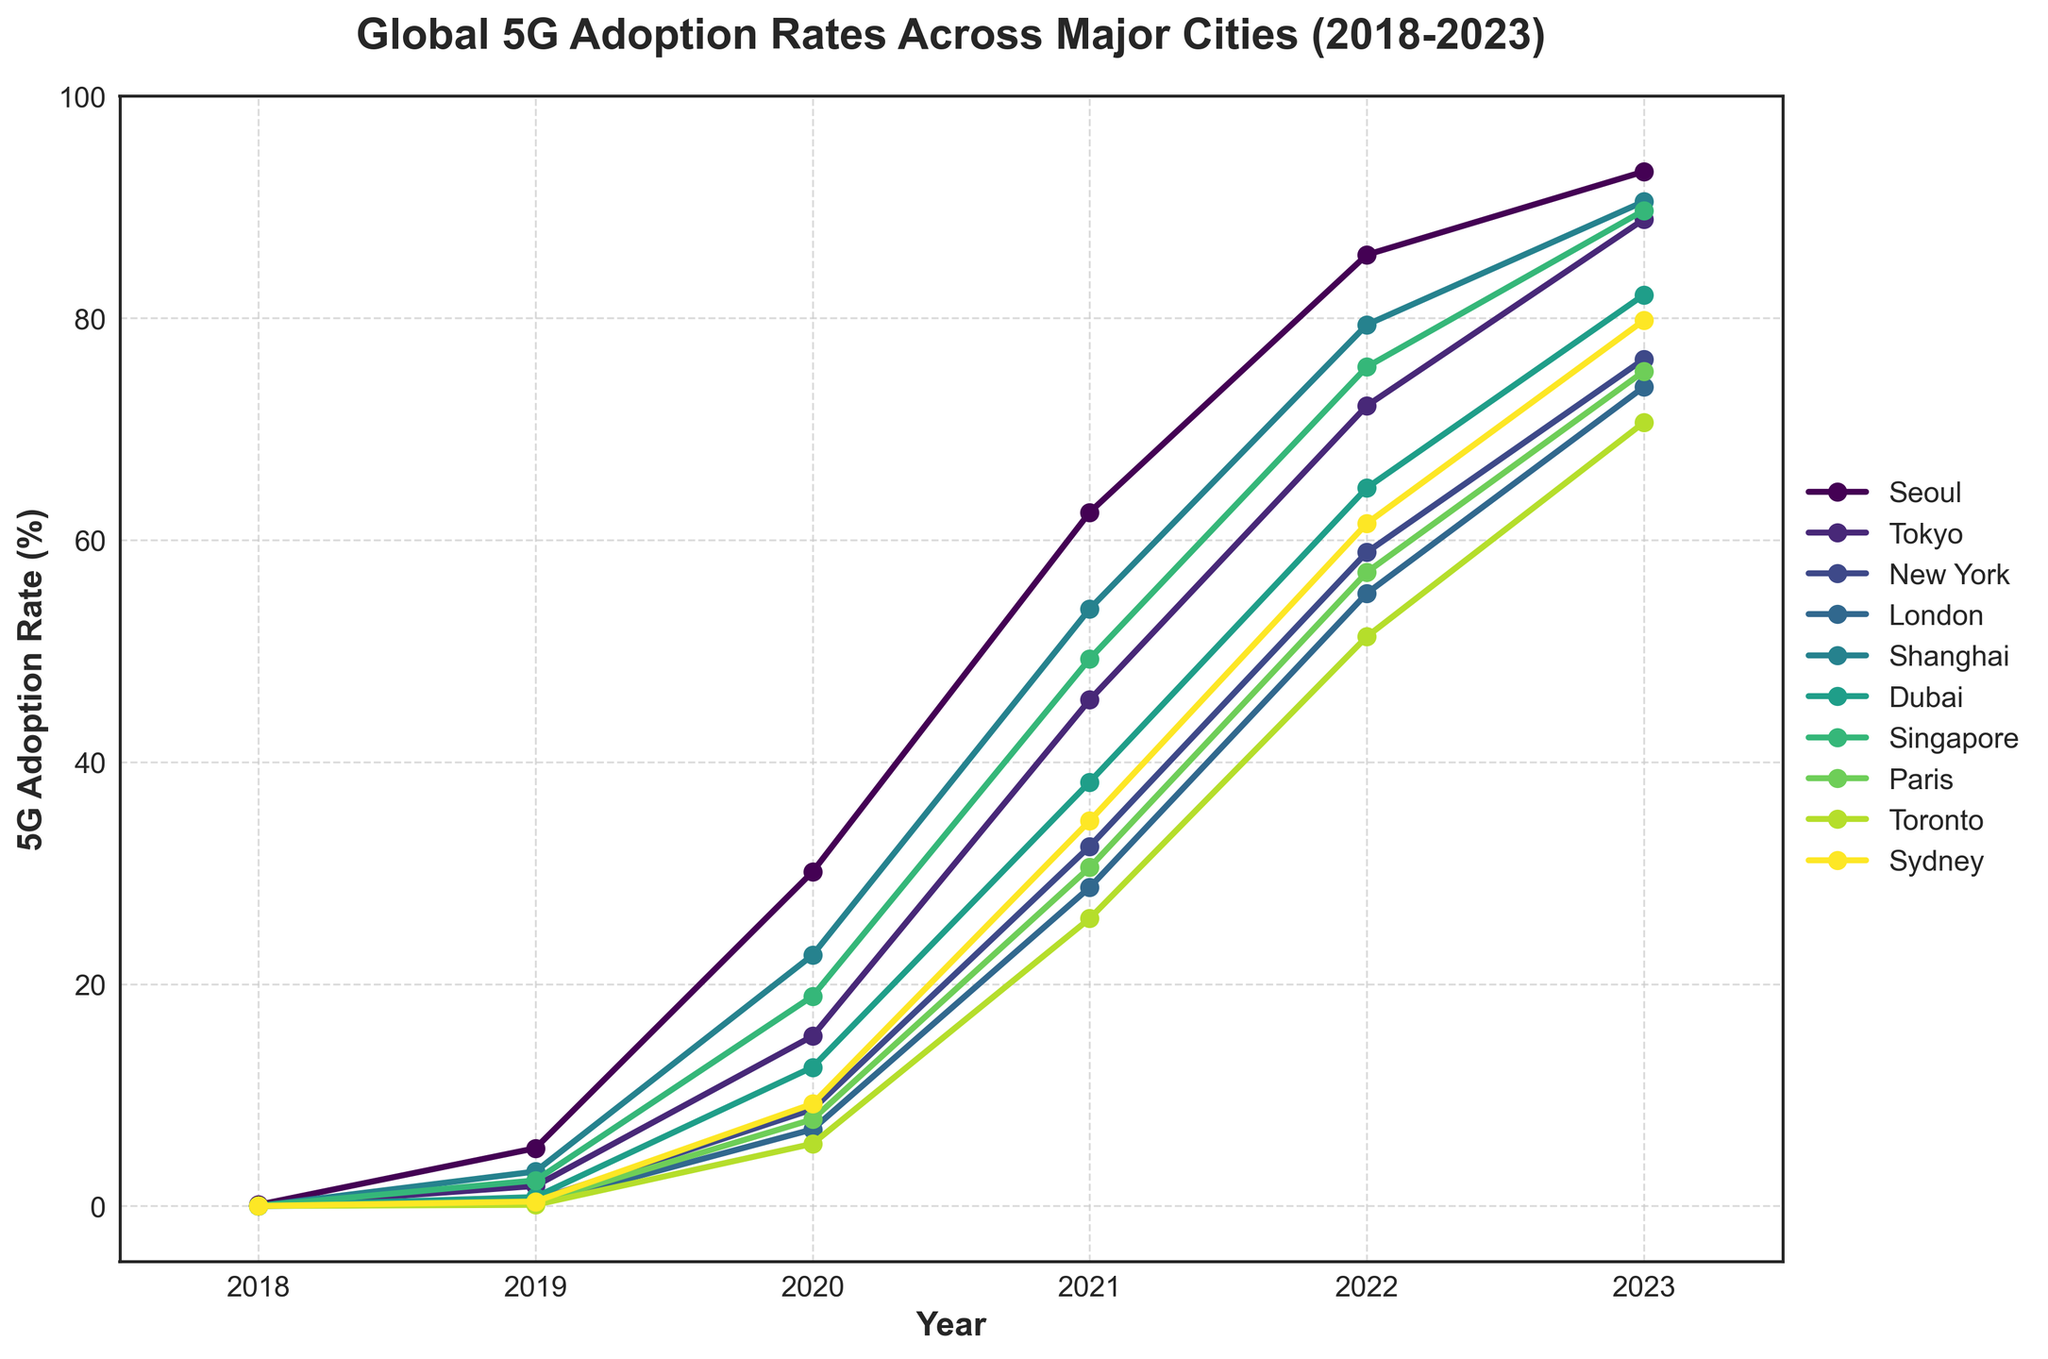Which city had the highest 5G adoption rate in 2023? Look at the year 2023 and identify the city with the highest percentage. Seoul had the highest rate at 93.2%.
Answer: Seoul Which city showed the fastest increase in 5G adoption rate from 2018 to 2020? Calculate the difference in adoption rates from 2018 to 2020 for each city. Seoul increased from 0.1% to 30.1%, a difference of 30%. This is the largest increase among the cities.
Answer: Seoul Between which consecutive years did Tokyo experience the largest increase in 5G adoption rate? Compare the year-to-year differences in adoption rates for Tokyo. The largest increase was from 2019 to 2020, where the rate increased from 1.8% to 15.3%, an increase of 13.5%.
Answer: 2019 to 2020 What was the average 5G adoption rate across all the cities in 2021? Sum the 5G adoption rates for all cities in 2021 and divide by the number of cities. The sum is (62.5 + 45.6 + 32.4 + 28.7 + 53.8 + 38.2 + 49.3 + 30.5 + 25.9 + 34.7) = 401.6, and there are 10 cities. The average is 401.6 / 10 = 40.16.
Answer: 40.16% Which city had the lowest 5G adoption rate in 2020? Look at the year 2020 and identify the city with the lowest percentage. Toronto had the lowest rate at 5.6%.
Answer: Toronto How much did Singapore's 5G adoption rate increase from 2018 to 2023? Subtract Singapore's 5G adoption rate in 2018 from its rate in 2023. It increased from 0% to 89.7%, an increase of 89.7%.
Answer: 89.7% Which city had a higher 5G adoption rate in 2022: New York or London? Compare the 2022 5G adoption rates of New York and London. New York had 58.9%, and London had 55.2%. New York's rate was higher.
Answer: New York What is the range of 5G adoption rates across all cities in 2023? Find the maximum and minimum 5G adoption rates in 2023 and subtract the minimum from the maximum. The maximum rate is 93.2% (Seoul), and the minimum is 70.6% (Toronto). The range is 93.2% - 70.6% = 22.6%.
Answer: 22.6% Between which years did Dubai's 5G adoption rate double? Identify the period when the rate approximately doubles by finding consecutive years where the rate increases by a factor of around 2. From 2019 to 2020, the rate increased from 0.8% to 12.5% (more than double). From 2020 to 2021, the rate went from 12.5% to 38.2% (more than double).
Answer: 2020 to 2021 